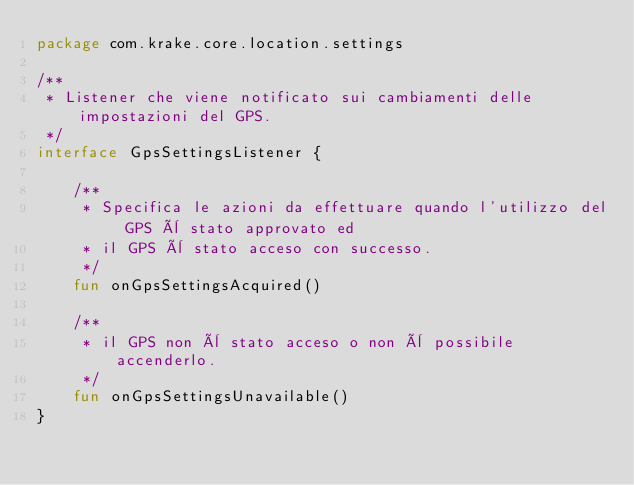Convert code to text. <code><loc_0><loc_0><loc_500><loc_500><_Kotlin_>package com.krake.core.location.settings

/**
 * Listener che viene notificato sui cambiamenti delle impostazioni del GPS.
 */
interface GpsSettingsListener {

    /**
     * Specifica le azioni da effettuare quando l'utilizzo del GPS è stato approvato ed
     * il GPS è stato acceso con successo.
     */
    fun onGpsSettingsAcquired()

    /**
     * il GPS non è stato acceso o non è possibile accenderlo.
     */
    fun onGpsSettingsUnavailable()
}</code> 